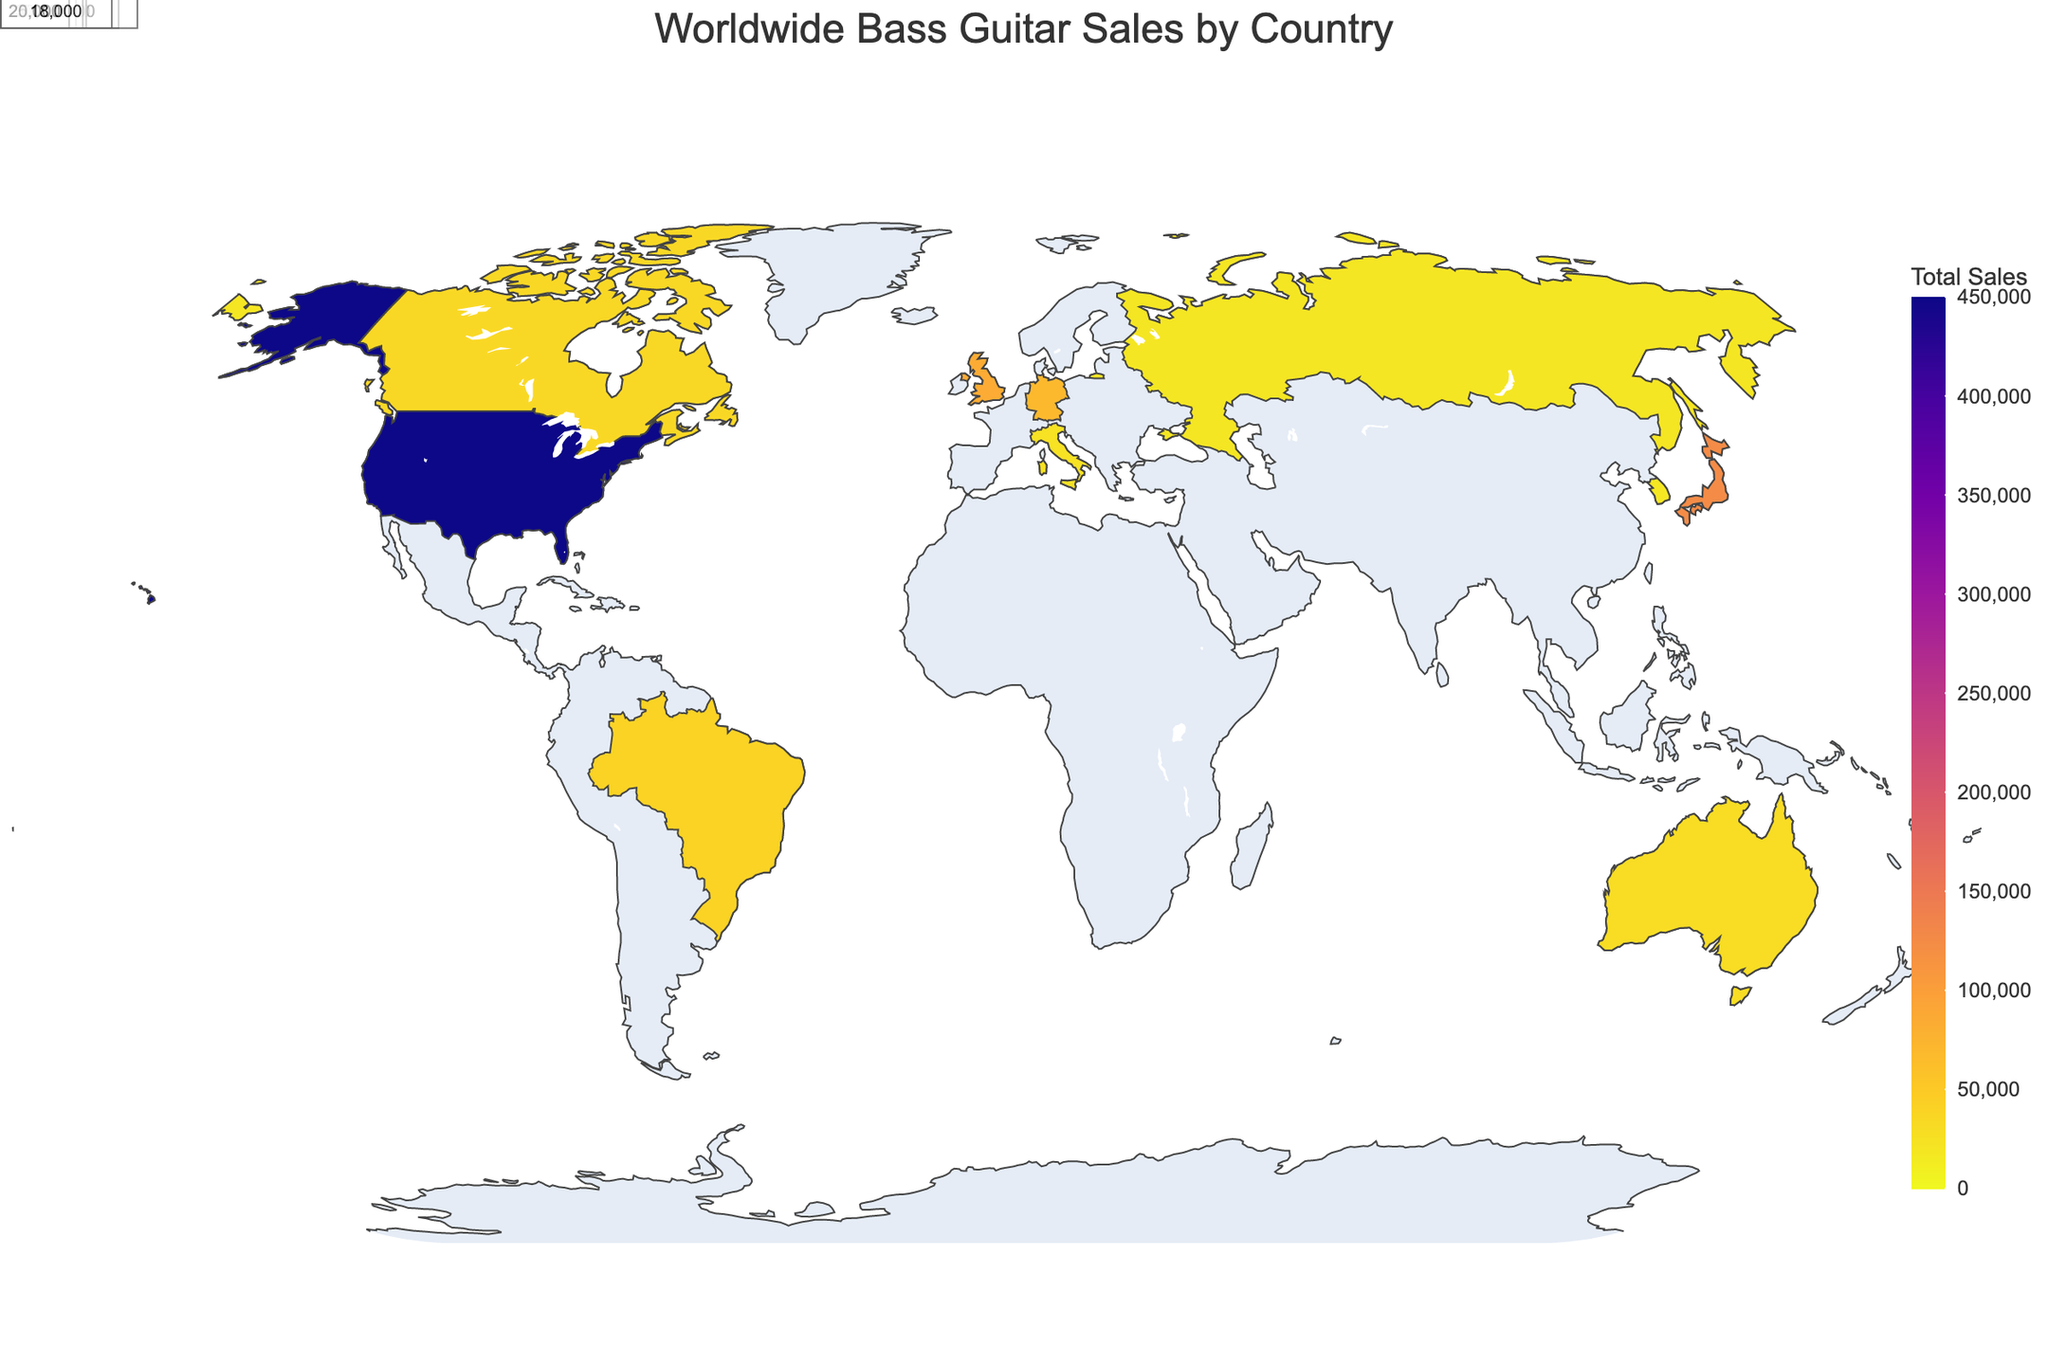What's the highest total sales of bass guitars by country? The figure uses color to indicate total sales, with deeper colors representing higher sales. The country with the deepest color is the United States, indicating it has the highest total sales.
Answer: United States Which country has the lowest total sales? By observing the lightest colors on the map, Russia has the lightest shade indicating the lowest total sales among the listed countries.
Answer: Russia What are the total sales of bass guitars in Japan? By finding Japan on the map and looking at the total sales value annotated near its position, we can see that Japan has total sales of 125,000.
Answer: 125,000 Which country features the top model "Rickenbacker 4003"? From the hover template information, check the corresponding top models for each country. The United Kingdom shows "Rickenbacker 4003" as its top model.
Answer: United Kingdom How do the total sales in Brazil compare to those in Canada? By examining the total sales values or colors for both Brazil and Canada, we see that Brazil has 40,000 total sales, and Canada has 35,000 total sales, showing Brazil has higher total sales than Canada.
Answer: Brazil What's the total sales difference between the United States and Germany? To find this, identify the total sales for the USA (450,000) and Germany (70,000), then calculate the difference: 450,000 - 70,000 = 380,000.
Answer: 380,000 Which brand is the top seller in South Korea? Locate South Korea on the map and observe the hover information to see that the top brand is Epiphone.
Answer: Epiphone What is the average total sales of bass guitars in the top three selling countries? Identify the top three selling countries (United States, Japan, and United Kingdom) with sales of 450,000, 125,000, and 85,000 respectively. The average is (450,000 + 125,000 + 85,000) / 3 = 220,000.
Answer: 220,000 What geographic pattern do you notice in terms of sales concentration? By observing the total sales distribution on the map, higher sales are concentrated in North America and Japan, while countries in South America, Europe, and Asia have varying but generally lower sales.
Answer: North America and Japan have high concentration What's the total sales of bass guitars in all the countries combined? Sum the total sales from each country: 450,000 (USA) + 125,000 (Japan) + 85,000 (UK) + 70,000 (Germany) + 40,000 (Brazil) + 35,000 (Canada) + 30,000 (Australia) + 25,000 (Italy) + 20,000 (Russia) + 18,000 (South Korea) = 898,000.
Answer: 898,000 